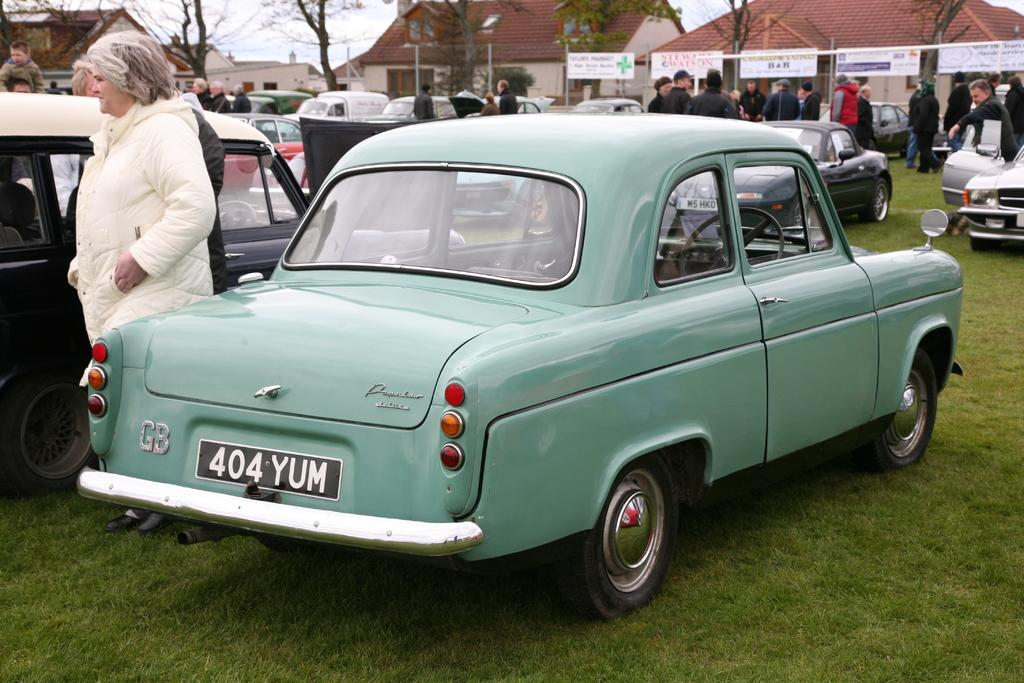What types of objects can be seen in the image? There are vehicles, people, light poles, trees, banners, houses, and windows in the image. Can you describe the setting of the image? The image features a combination of urban and natural elements, including houses, trees, and light poles. What is visible in the sky in the image? The sky is visible in the image. How many types of structures are present in the image? There are at least two types of structures in the image: houses and light poles. What type of gold object can be seen in the image? There is no gold object present in the image. Can you describe the tail of the animal in the image? There are no animals, let alone one with a tail, present in the image. 